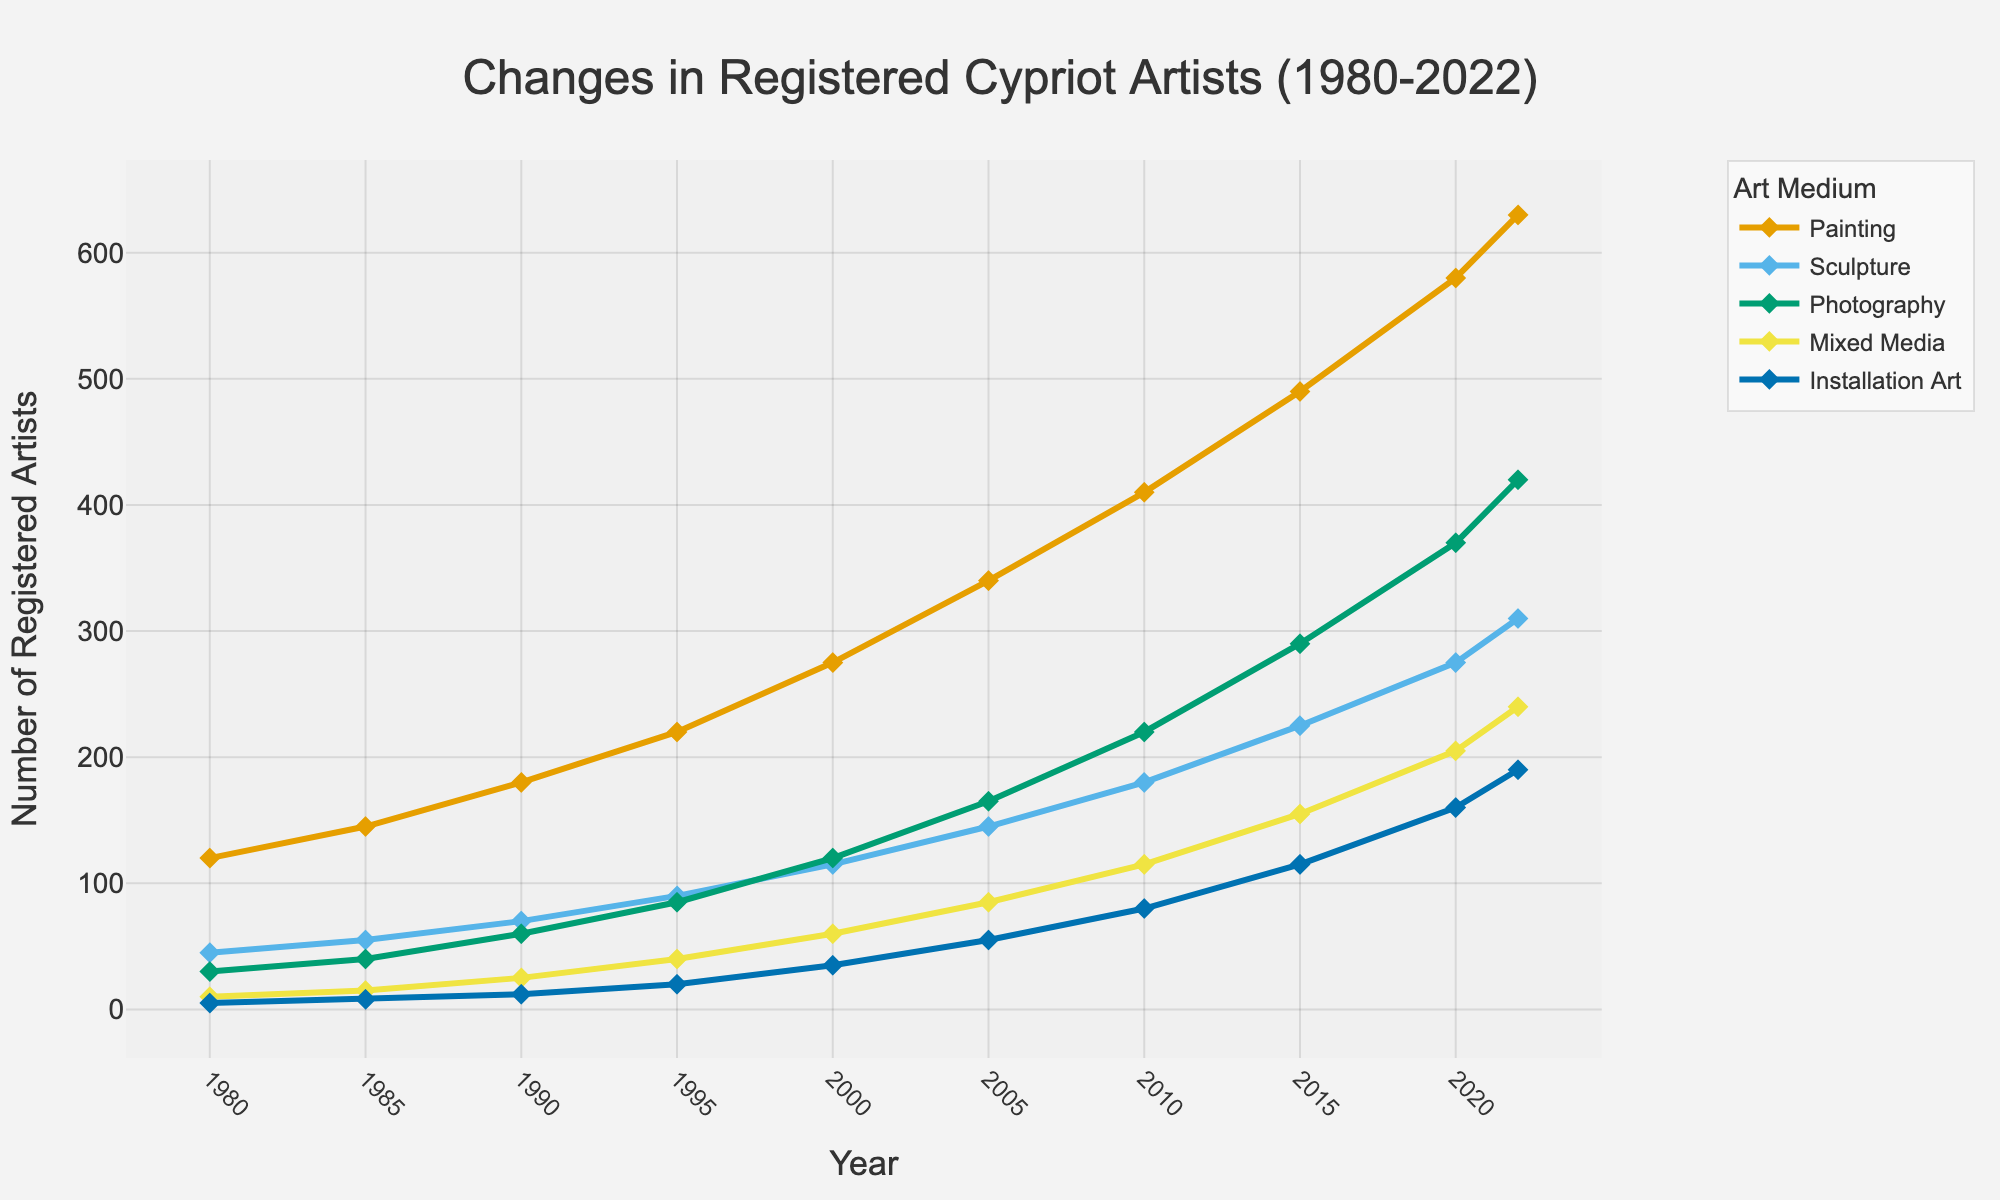How has the number of registered artists in sculpture changed from 1980 to 2022? By looking at the line chart for the Sculpture category, identify the values at 1980 and at 2022. Subtract the 1980 value from the 2022 value to determine the change. In 1980, there were 45 artists and in 2022, there were 310 artists. The change is 310 - 45 = 265.
Answer: The number of registered artists in sculpture increased by 265 Which medium saw the largest absolute increase in the number of registered artists from 1980 to 2022? Compare the increase for each medium from 1980 to 2022 by subtracting the initial value (1980) from the final value (2022) for all mediums. For Painting: 630 - 120 = 510; for Sculpture: 310 - 45 = 265; for Photography: 420 - 30 = 390; for Mixed Media: 240 - 10 = 230; for Installation Art: 190 - 5 = 185. The largest increase is in Painting with 510.
Answer: Painting saw the largest absolute increase with 510 artists Which medium had the smallest number of registered artists in the year 2000? Look at the values for each medium in the year 2000: Painting (275), Sculpture (115), Photography (120), Mixed Media (60), Installation Art (35). The smallest value is 35 for Installation Art.
Answer: Installation Art had the smallest number of registered artists By how much did Photography surpass Sculpture in 2022? Identify the number of registered artists in Photography and Sculpture in 2022 from the chart. Photography had 420 artists, while Sculpture had 310 artists. Subtract the number of Sculptors from the number of Photographers: 420 - 310 = 110.
Answer: Photography surpassed Sculpture by 110 artists What is the trend of registered artists in Installation Art from 1980 to 2022? Observe the trajectory of the line representing Installation Art from 1980 to 2022. It shows a continuously increasing trend starting from 5 in 1980 to 190 in 2022.
Answer: The trend is increasing In which years did the number of registered artists in Mixed Media exceed 100? Locate the points on the Mixed Media line where the number is over 100. This occurs in 2005, 2010, 2015, 2020, and 2022.
Answer: 2005, 2010, 2015, 2020, and 2022 Which medium had the sharpest increase in registered artists between 2015 and 2020? Calculate the increase between 2015 and 2020 for each medium and compare. Painting: 580 - 490 = 90; Sculpture: 275 - 225 = 50; Photography: 370 - 290 = 80; Mixed Media: 205 - 155 = 50; Installation Art: 160 - 115 = 45. Painting had the largest increase of 90.
Answer: Painting had the sharpest increase What’s the average number of registered artists in Painting over the given years? Sum up the number of registered artists in Painting for all years and divide by the number of years. (120 + 145 + 180 + 220 + 275 + 340 + 410 + 490 + 580 + 630) / 10 = 3390 / 10 = 339.
Answer: The average is 339 Compare the number of registered artists in Painting and Photography in 2015. Which one had more, and by how much? Identify the number of registered artists in Painting and Photography in 2015: Painting (490) and Photography (290). Subtract the number of Photographers from the number of Painters: 490 - 290 = 200.
Answer: Painting had 200 more artists When did the number of registered artists in Mixed Media first surpass 150? Look at the line representing Mixed Media and identify the first year it crosses 150. This occurs between 2010 (115) and 2015 (155). The first year it surpasses 150 is 2015.
Answer: 2015 